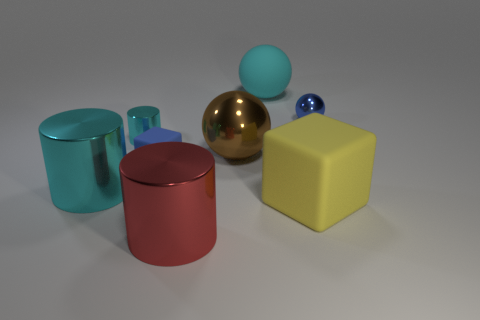How do the objects' colors contrast with each other? The objects in the image present a pleasing contrast. The cyan and red cylinders create a vibrant visual tension, while the yellow cube and blue sphere offer a cheerful and bold contrast against the neutral background. The gold sphere adds a touch of elegance and richness to the scene. 